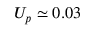<formula> <loc_0><loc_0><loc_500><loc_500>U _ { p } \simeq 0 . 0 3</formula> 